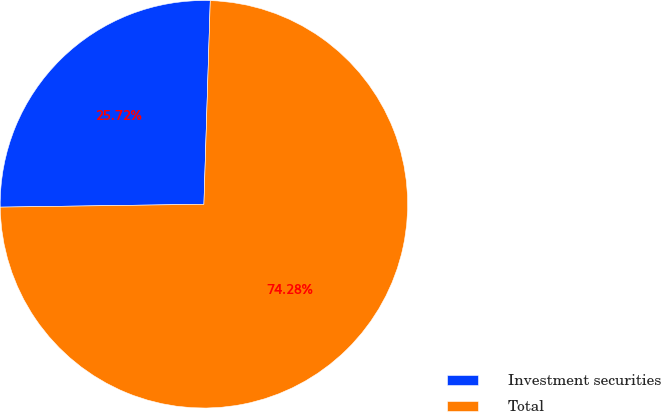Convert chart to OTSL. <chart><loc_0><loc_0><loc_500><loc_500><pie_chart><fcel>Investment securities<fcel>Total<nl><fcel>25.72%<fcel>74.28%<nl></chart> 